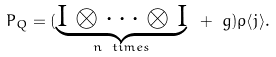Convert formula to latex. <formula><loc_0><loc_0><loc_500><loc_500>P _ { Q } = ( \underbrace { I \otimes \dots \otimes I } _ { n \ t i m e s } \ + \ g ) \rho \langle j \rangle .</formula> 